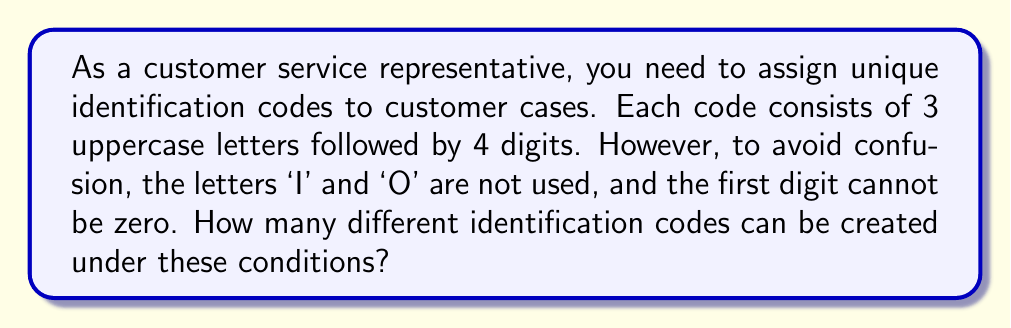Can you solve this math problem? Let's break this down step by step:

1) For the letters:
   - We have 26 uppercase letters in the alphabet.
   - We can't use 'I' and 'O', so we have 24 choices for each letter position.
   - We need to choose 3 letters, and the order matters.
   - This is a permutation with repetition allowed.
   - Number of letter combinations: $24^3$

2) For the digits:
   - We have 10 digits (0-9) to choose from.
   - The first digit can't be zero, so we have 9 choices for the first position.
   - For the remaining 3 positions, we can use any digit from 0-9.
   - Number of digit combinations: $9 \times 10^3$

3) Total number of possible codes:
   - We multiply the number of letter combinations by the number of digit combinations.
   - Total = $24^3 \times 9 \times 10^3$

4) Calculating the result:
   $$\begin{align}
   \text{Total} &= 24^3 \times 9 \times 10^3 \\
                &= 13,824 \times 9 \times 1,000 \\
                &= 124,416,000
   \end{align}$$

Therefore, there are 124,416,000 unique identification codes that can be created under these conditions.
Answer: 124,416,000 